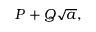<formula> <loc_0><loc_0><loc_500><loc_500>P + Q { \sqrt { a } } ,</formula> 